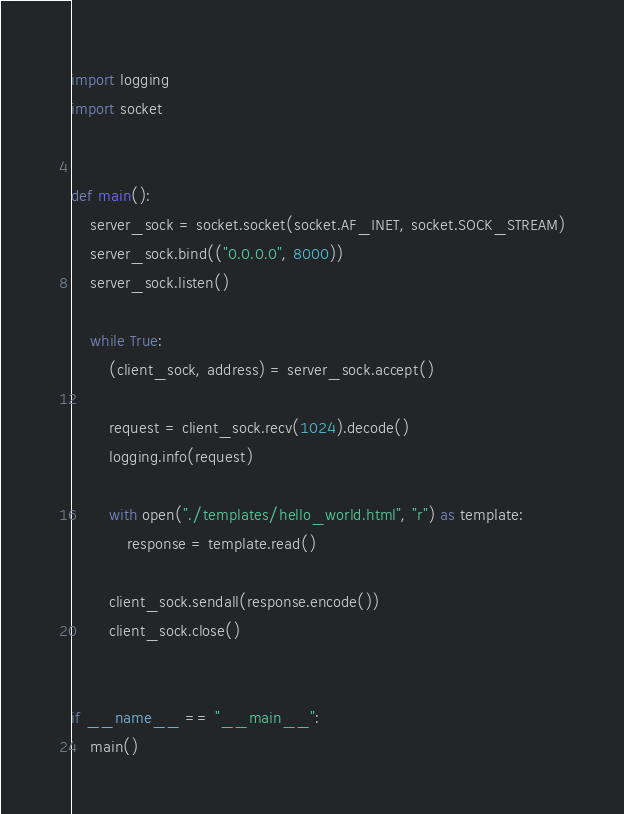<code> <loc_0><loc_0><loc_500><loc_500><_Python_>import logging
import socket


def main():
    server_sock = socket.socket(socket.AF_INET, socket.SOCK_STREAM)
    server_sock.bind(("0.0.0.0", 8000))
    server_sock.listen()

    while True:
        (client_sock, address) = server_sock.accept()

        request = client_sock.recv(1024).decode()
        logging.info(request)

        with open("./templates/hello_world.html", "r") as template:
            response = template.read()

        client_sock.sendall(response.encode())
        client_sock.close()


if __name__ == "__main__":
    main()
</code> 